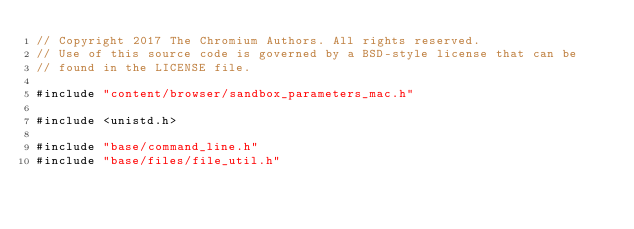<code> <loc_0><loc_0><loc_500><loc_500><_ObjectiveC_>// Copyright 2017 The Chromium Authors. All rights reserved.
// Use of this source code is governed by a BSD-style license that can be
// found in the LICENSE file.

#include "content/browser/sandbox_parameters_mac.h"

#include <unistd.h>

#include "base/command_line.h"
#include "base/files/file_util.h"</code> 